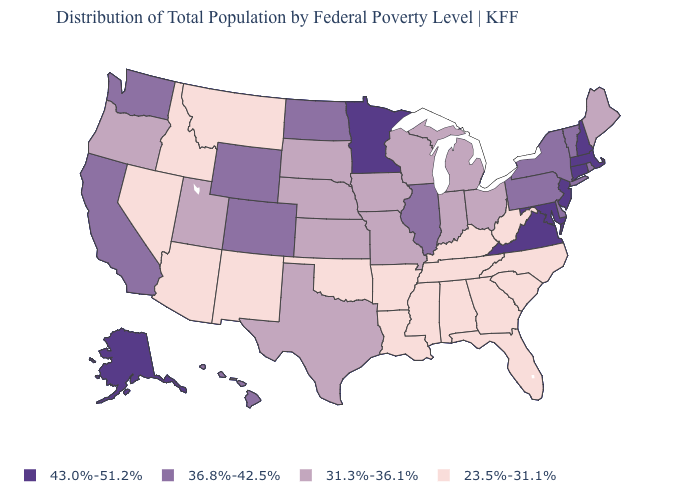Does Idaho have a higher value than New Mexico?
Be succinct. No. Is the legend a continuous bar?
Concise answer only. No. Is the legend a continuous bar?
Write a very short answer. No. What is the value of Nevada?
Give a very brief answer. 23.5%-31.1%. What is the value of Montana?
Be succinct. 23.5%-31.1%. What is the value of Pennsylvania?
Write a very short answer. 36.8%-42.5%. Name the states that have a value in the range 36.8%-42.5%?
Write a very short answer. California, Colorado, Delaware, Hawaii, Illinois, New York, North Dakota, Pennsylvania, Rhode Island, Vermont, Washington, Wyoming. What is the value of Delaware?
Quick response, please. 36.8%-42.5%. What is the highest value in the USA?
Short answer required. 43.0%-51.2%. Which states have the lowest value in the West?
Short answer required. Arizona, Idaho, Montana, Nevada, New Mexico. Does Virginia have the highest value in the USA?
Quick response, please. Yes. Does the first symbol in the legend represent the smallest category?
Quick response, please. No. Does South Carolina have the lowest value in the USA?
Be succinct. Yes. Name the states that have a value in the range 31.3%-36.1%?
Write a very short answer. Indiana, Iowa, Kansas, Maine, Michigan, Missouri, Nebraska, Ohio, Oregon, South Dakota, Texas, Utah, Wisconsin. What is the value of Utah?
Short answer required. 31.3%-36.1%. 